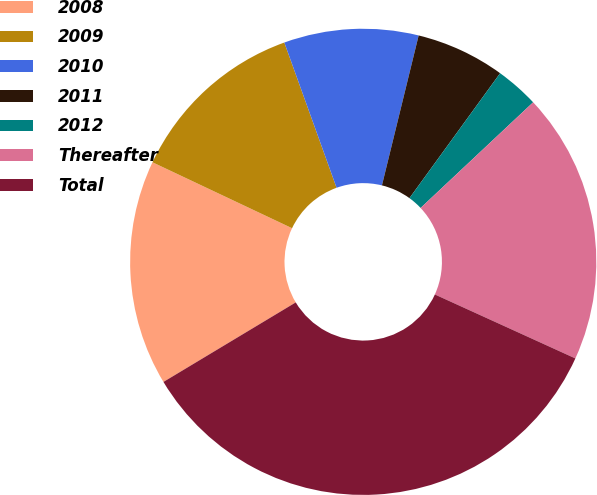Convert chart. <chart><loc_0><loc_0><loc_500><loc_500><pie_chart><fcel>2008<fcel>2009<fcel>2010<fcel>2011<fcel>2012<fcel>Thereafter<fcel>Total<nl><fcel>15.64%<fcel>12.48%<fcel>9.32%<fcel>6.17%<fcel>3.01%<fcel>18.8%<fcel>34.59%<nl></chart> 